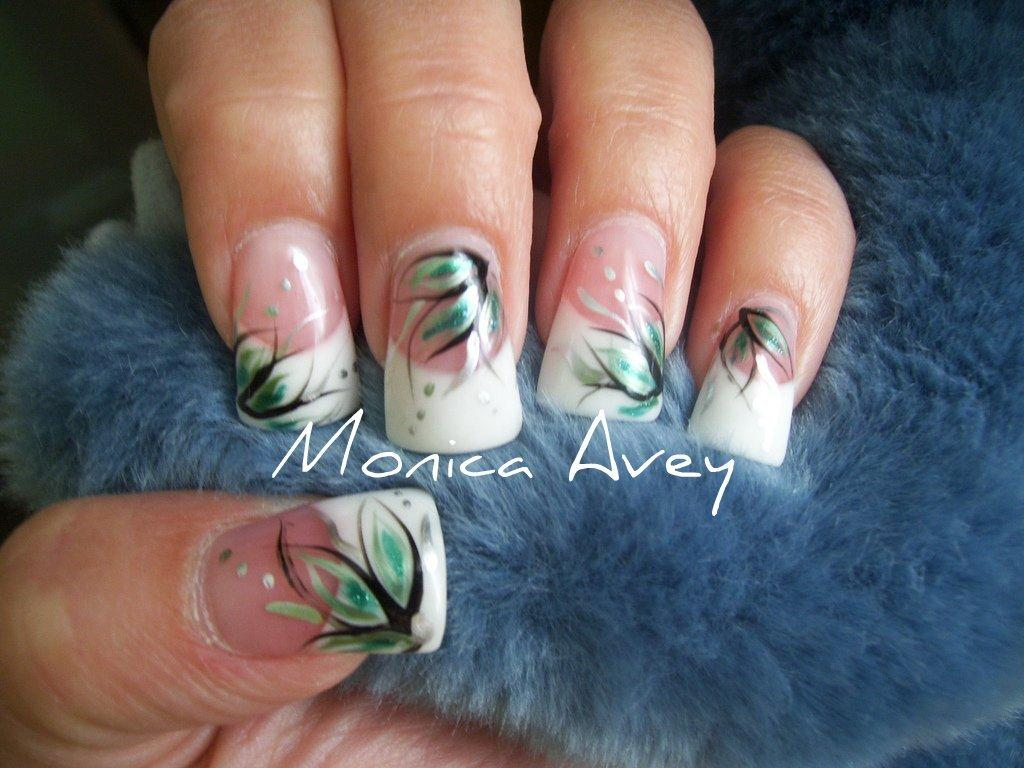What is the main subject of the image? The main subject of the image is a human hand with nail paint. What is the hand doing or resting on in the image? The hand appears to be holding or resting on a cloth-like material. Are there any words or letters visible in the image? Yes, there is text present in the image. Is the hand's aunt nearby in the image? There is no mention of an aunt or any other person in the image, so it cannot be determined if the hand's aunt is nearby. What role does the manager play in the image? There is no mention of a manager or any other person in the image, so it cannot be determined if a manager is involved or present. 